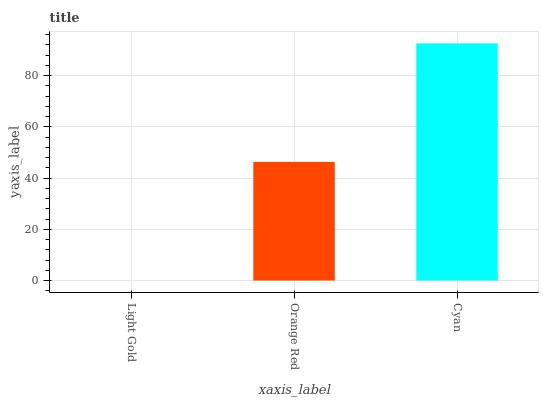Is Light Gold the minimum?
Answer yes or no. Yes. Is Cyan the maximum?
Answer yes or no. Yes. Is Orange Red the minimum?
Answer yes or no. No. Is Orange Red the maximum?
Answer yes or no. No. Is Orange Red greater than Light Gold?
Answer yes or no. Yes. Is Light Gold less than Orange Red?
Answer yes or no. Yes. Is Light Gold greater than Orange Red?
Answer yes or no. No. Is Orange Red less than Light Gold?
Answer yes or no. No. Is Orange Red the high median?
Answer yes or no. Yes. Is Orange Red the low median?
Answer yes or no. Yes. Is Light Gold the high median?
Answer yes or no. No. Is Light Gold the low median?
Answer yes or no. No. 